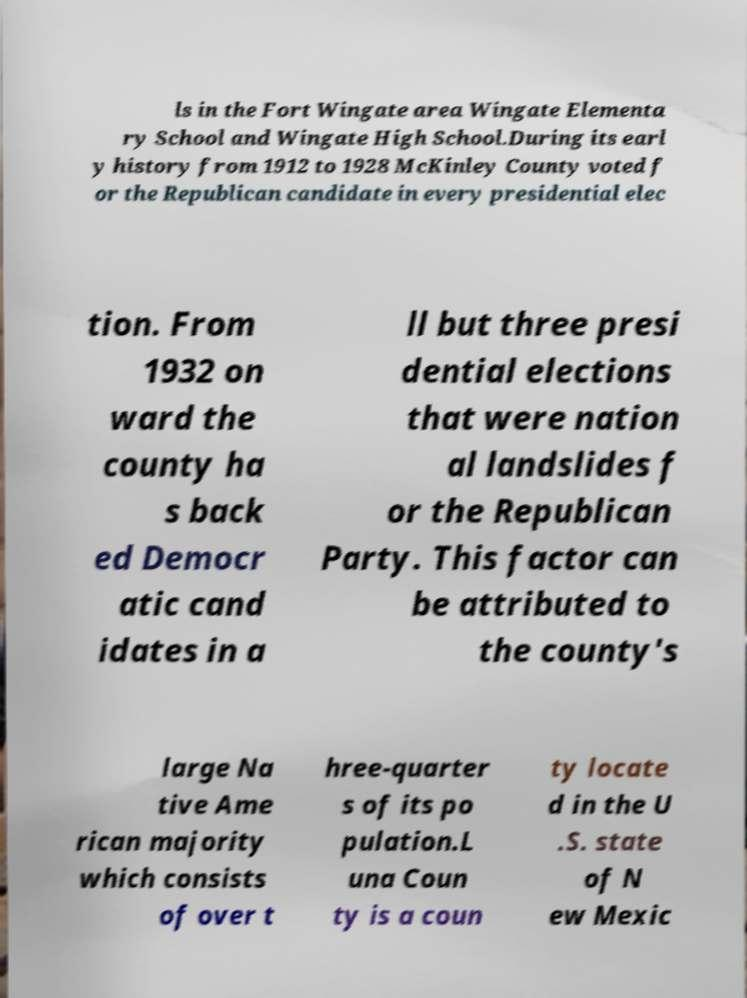What messages or text are displayed in this image? I need them in a readable, typed format. ls in the Fort Wingate area Wingate Elementa ry School and Wingate High School.During its earl y history from 1912 to 1928 McKinley County voted f or the Republican candidate in every presidential elec tion. From 1932 on ward the county ha s back ed Democr atic cand idates in a ll but three presi dential elections that were nation al landslides f or the Republican Party. This factor can be attributed to the county's large Na tive Ame rican majority which consists of over t hree-quarter s of its po pulation.L una Coun ty is a coun ty locate d in the U .S. state of N ew Mexic 